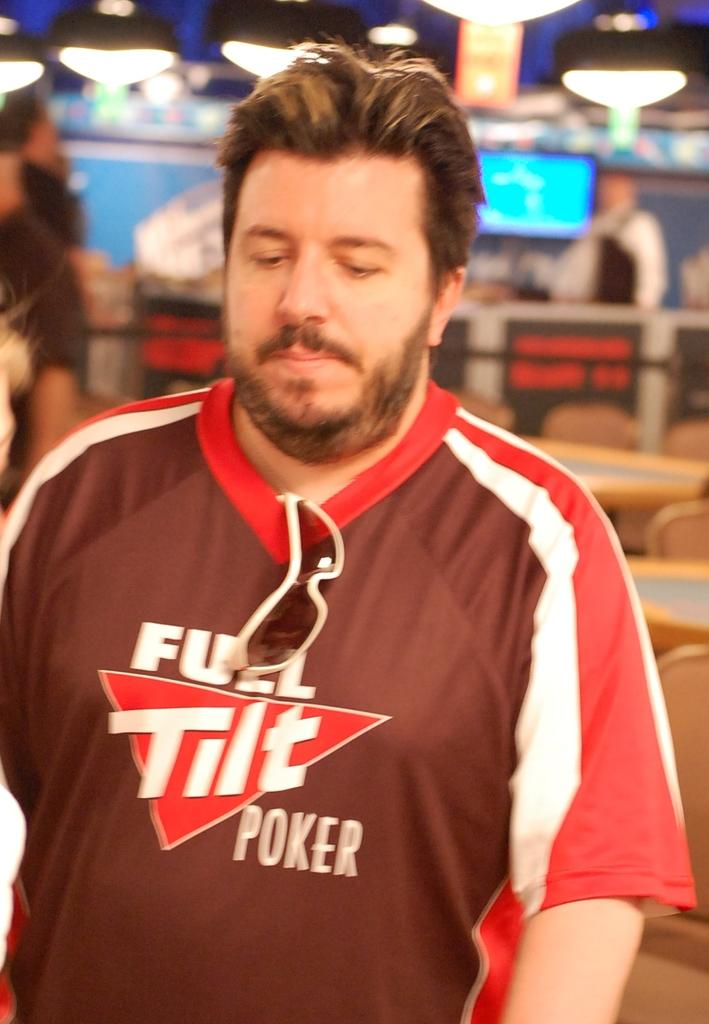Provide a one-sentence caption for the provided image. A man is standing at a poker table with a Full Tilt Poker shirt on. 